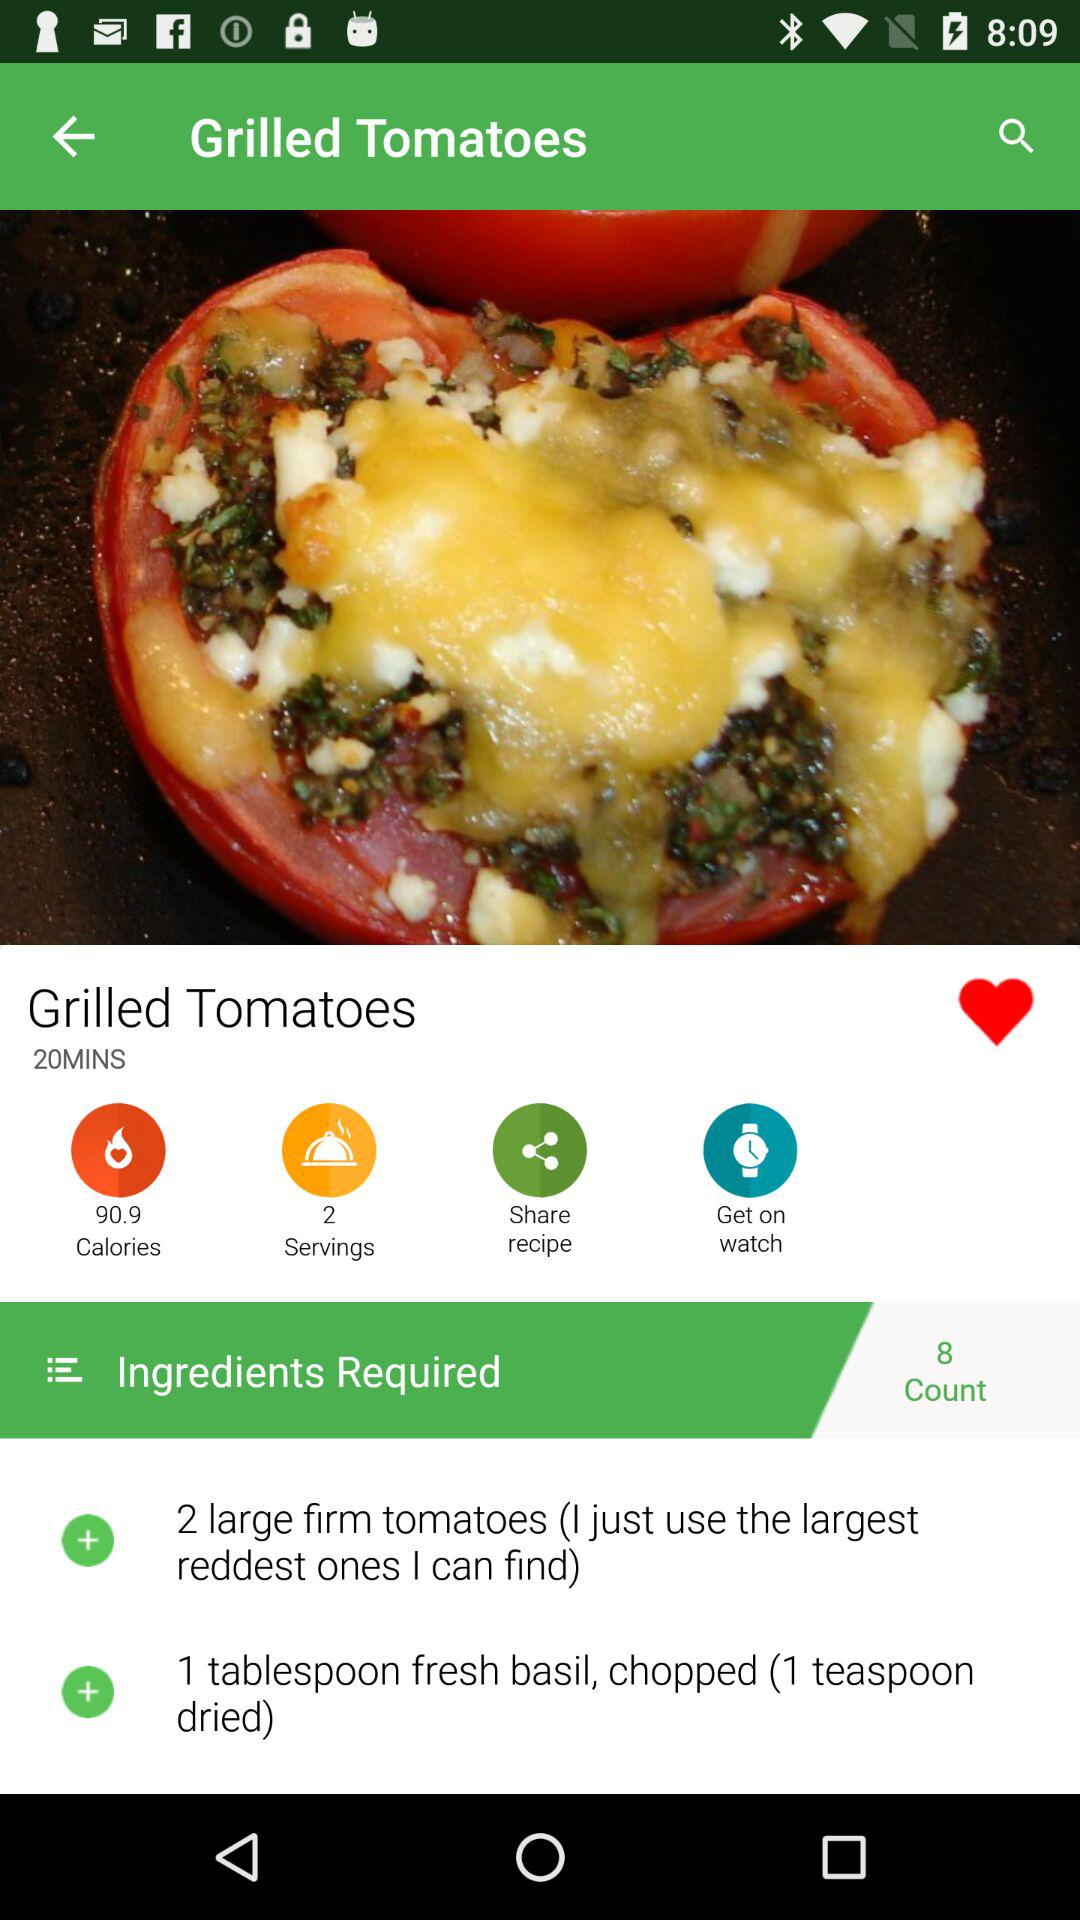How many tablespoons of fresh basil do you need to cook "Grilled Tomatoes"? You need 1 tablespoon of fresh basil to cook "Grilled Tomatoes". 